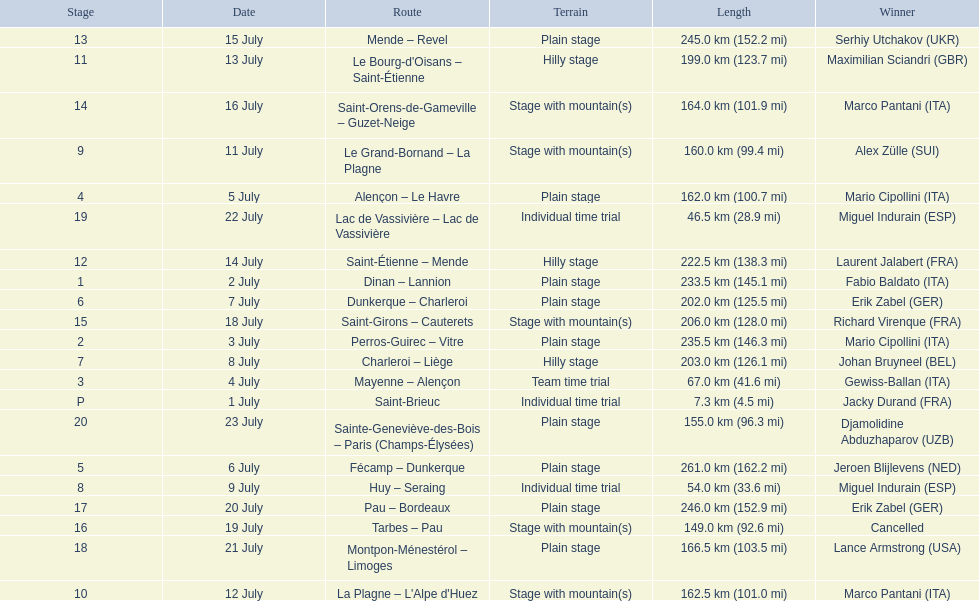What were the lengths of all the stages of the 1995 tour de france? 7.3 km (4.5 mi), 233.5 km (145.1 mi), 235.5 km (146.3 mi), 67.0 km (41.6 mi), 162.0 km (100.7 mi), 261.0 km (162.2 mi), 202.0 km (125.5 mi), 203.0 km (126.1 mi), 54.0 km (33.6 mi), 160.0 km (99.4 mi), 162.5 km (101.0 mi), 199.0 km (123.7 mi), 222.5 km (138.3 mi), 245.0 km (152.2 mi), 164.0 km (101.9 mi), 206.0 km (128.0 mi), 149.0 km (92.6 mi), 246.0 km (152.9 mi), 166.5 km (103.5 mi), 46.5 km (28.9 mi), 155.0 km (96.3 mi). Of those, which one occurred on july 8th? 203.0 km (126.1 mi). 